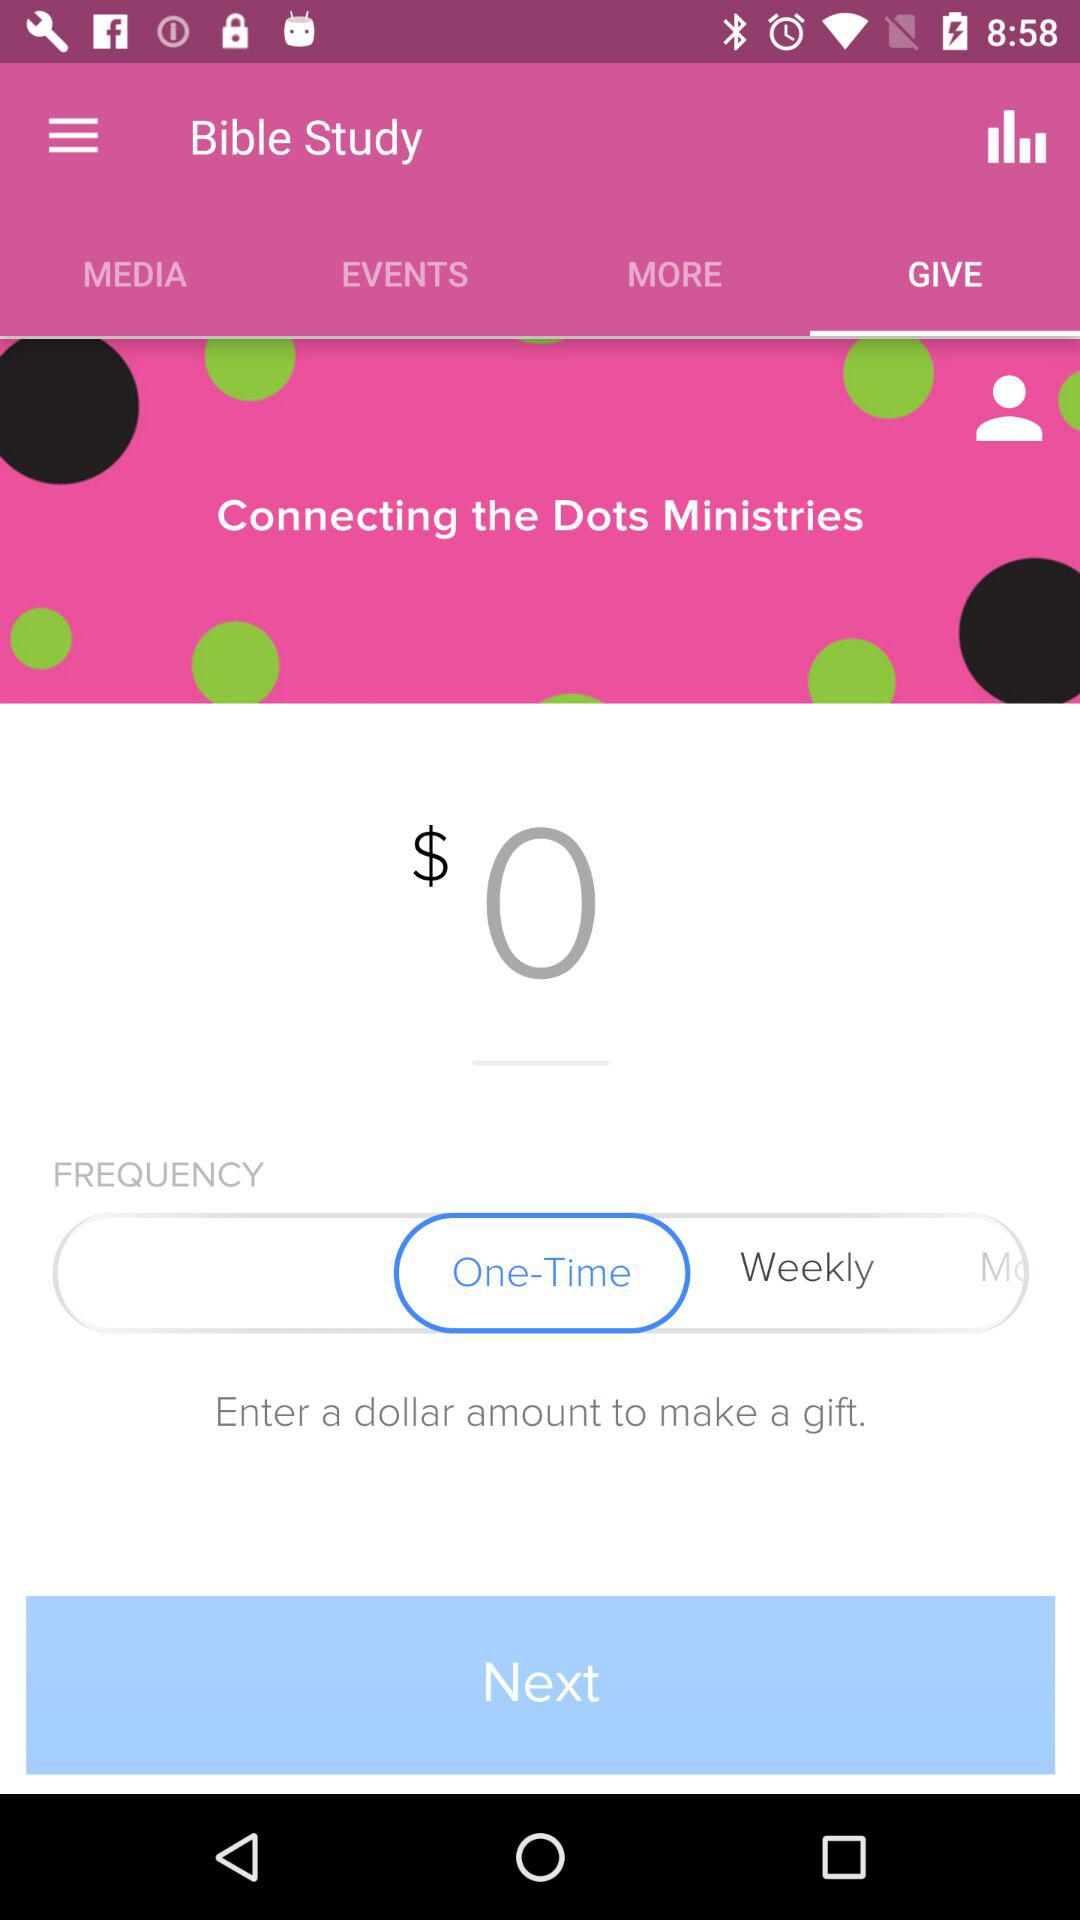What amount is entered to make a gift?
When the provided information is insufficient, respond with <no answer>. <no answer> 